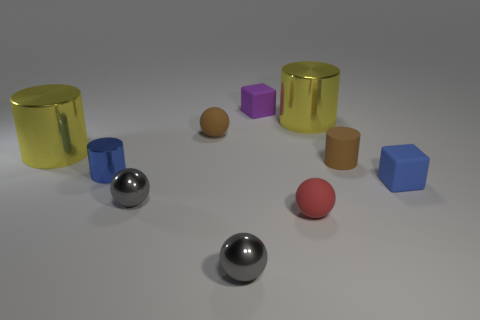Subtract all rubber cylinders. How many cylinders are left? 3 Subtract all yellow cylinders. How many cylinders are left? 2 Subtract 4 cylinders. How many cylinders are left? 0 Subtract all purple cubes. How many gray cylinders are left? 0 Add 5 brown rubber cylinders. How many brown rubber cylinders exist? 6 Subtract 0 yellow blocks. How many objects are left? 10 Subtract all blocks. How many objects are left? 8 Subtract all cyan balls. Subtract all blue cylinders. How many balls are left? 4 Subtract all small purple metal balls. Subtract all small blue metal cylinders. How many objects are left? 9 Add 8 large things. How many large things are left? 10 